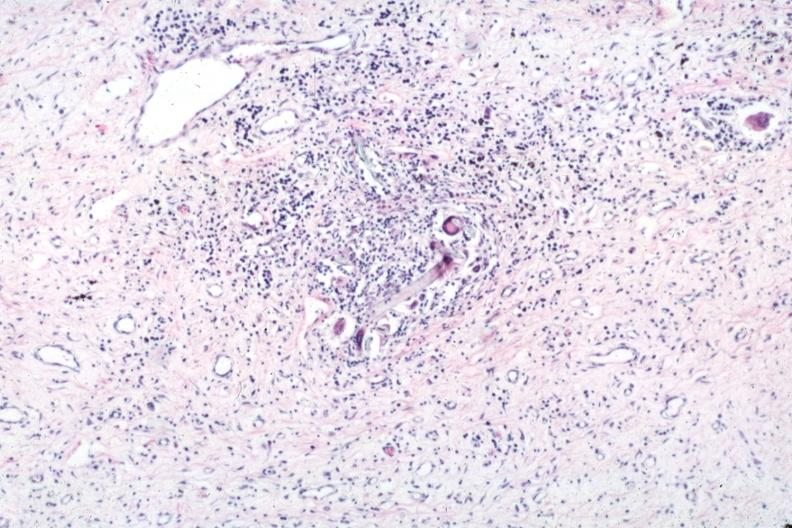how does this image show typical lesion?
Answer the question using a single word or phrase. With giant cells and foreign material 